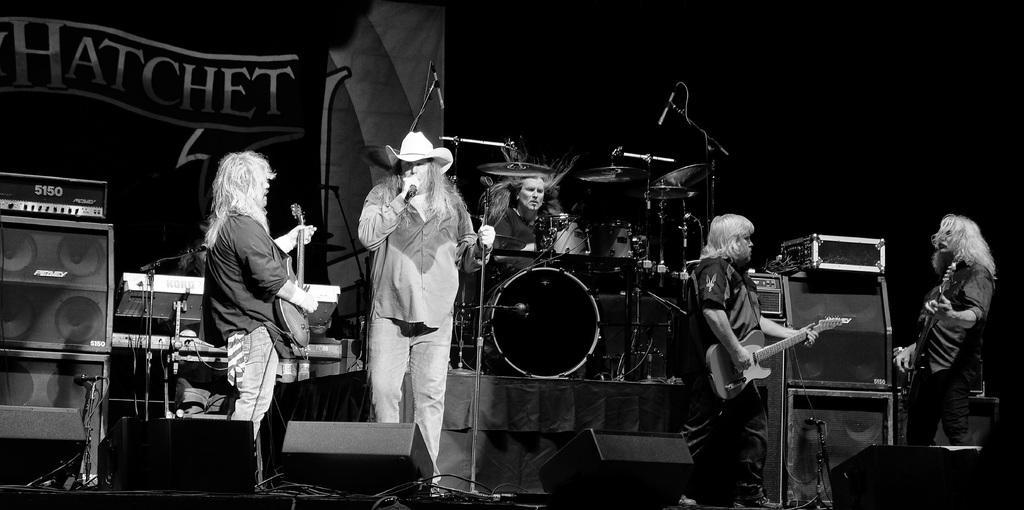How would you summarize this image in a sentence or two? In this image I see 5 persons and in which 3 of them are holding guitars, one of them is holding mic and In the background I see the speakers, a man with drums and an equipment. 